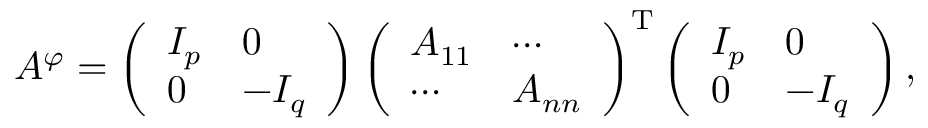Convert formula to latex. <formula><loc_0><loc_0><loc_500><loc_500>A ^ { \varphi } = \left ( { \begin{array} { l l } { I _ { p } } & { 0 } \\ { 0 } & { - I _ { q } } \end{array} } \right ) \left ( { \begin{array} { l l } { A _ { 1 1 } } & { \cdots } \\ { \cdots } & { A _ { n n } } \end{array} } \right ) ^ { T } \left ( { \begin{array} { l l } { I _ { p } } & { 0 } \\ { 0 } & { - I _ { q } } \end{array} } \right ) ,</formula> 